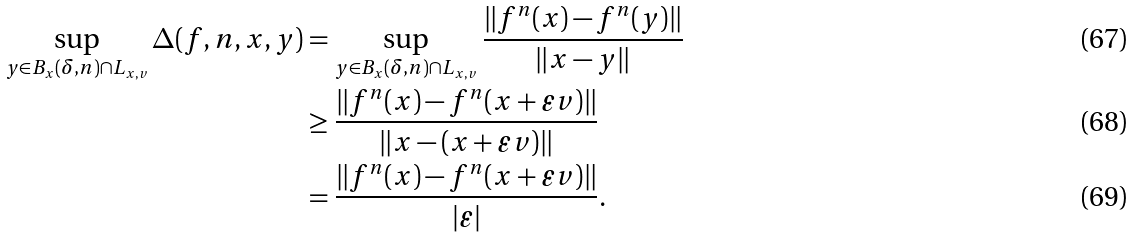Convert formula to latex. <formula><loc_0><loc_0><loc_500><loc_500>\sup _ { y \in B _ { x } ( \delta , n ) \cap L _ { x , v } } \Delta ( f , n , x , y ) & = \sup _ { y \in B _ { x } ( \delta , n ) \cap L _ { x , v } } \frac { \| f ^ { n } ( x ) - f ^ { n } ( y ) \| } { \| x - y \| } \\ & \geq \frac { \| f ^ { n } ( x ) - f ^ { n } ( x + \varepsilon v ) \| } { \| x - ( x + \varepsilon v ) \| } \\ & = \frac { \| f ^ { n } ( x ) - f ^ { n } ( x + \varepsilon v ) \| } { | \varepsilon | } .</formula> 